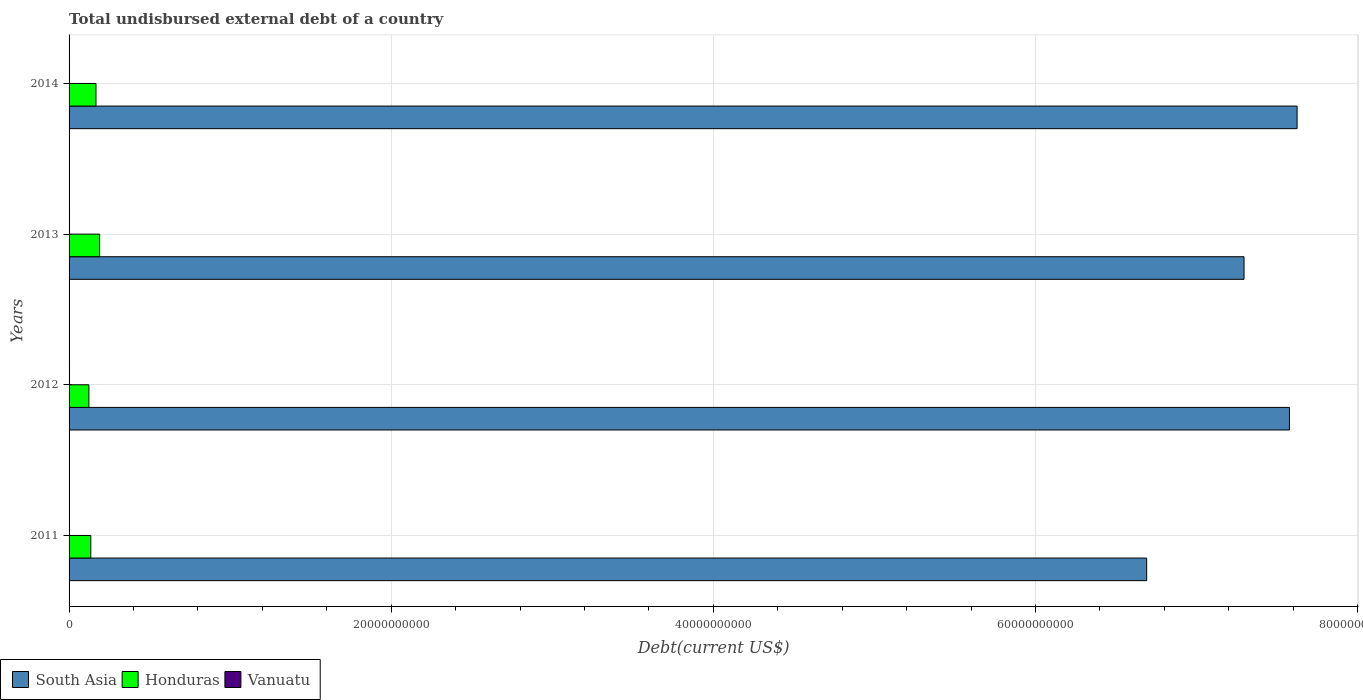How many different coloured bars are there?
Keep it short and to the point. 3. Are the number of bars on each tick of the Y-axis equal?
Offer a terse response. Yes. What is the label of the 2nd group of bars from the top?
Your answer should be compact. 2013. In how many cases, is the number of bars for a given year not equal to the number of legend labels?
Your answer should be very brief. 0. What is the total undisbursed external debt in Vanuatu in 2011?
Keep it short and to the point. 1.28e+07. Across all years, what is the maximum total undisbursed external debt in South Asia?
Ensure brevity in your answer.  7.62e+1. Across all years, what is the minimum total undisbursed external debt in South Asia?
Provide a short and direct response. 6.69e+1. In which year was the total undisbursed external debt in Honduras maximum?
Offer a terse response. 2013. In which year was the total undisbursed external debt in Vanuatu minimum?
Ensure brevity in your answer.  2011. What is the total total undisbursed external debt in Honduras in the graph?
Give a very brief answer. 6.15e+09. What is the difference between the total undisbursed external debt in Honduras in 2011 and that in 2014?
Give a very brief answer. -3.20e+08. What is the difference between the total undisbursed external debt in Honduras in 2011 and the total undisbursed external debt in Vanuatu in 2012?
Your response must be concise. 1.32e+09. What is the average total undisbursed external debt in South Asia per year?
Ensure brevity in your answer.  7.30e+1. In the year 2014, what is the difference between the total undisbursed external debt in Honduras and total undisbursed external debt in Vanuatu?
Offer a terse response. 1.64e+09. What is the ratio of the total undisbursed external debt in Vanuatu in 2011 to that in 2012?
Your response must be concise. 0.46. What is the difference between the highest and the second highest total undisbursed external debt in Vanuatu?
Give a very brief answer. 4.23e+05. What is the difference between the highest and the lowest total undisbursed external debt in South Asia?
Your answer should be very brief. 9.34e+09. In how many years, is the total undisbursed external debt in Vanuatu greater than the average total undisbursed external debt in Vanuatu taken over all years?
Offer a terse response. 3. Is the sum of the total undisbursed external debt in Honduras in 2011 and 2013 greater than the maximum total undisbursed external debt in South Asia across all years?
Keep it short and to the point. No. What does the 1st bar from the top in 2014 represents?
Ensure brevity in your answer.  Vanuatu. What does the 1st bar from the bottom in 2013 represents?
Your response must be concise. South Asia. How many bars are there?
Ensure brevity in your answer.  12. Are all the bars in the graph horizontal?
Provide a short and direct response. Yes. What is the difference between two consecutive major ticks on the X-axis?
Make the answer very short. 2.00e+1. Does the graph contain grids?
Provide a short and direct response. Yes. What is the title of the graph?
Your answer should be very brief. Total undisbursed external debt of a country. Does "Hungary" appear as one of the legend labels in the graph?
Your answer should be very brief. No. What is the label or title of the X-axis?
Give a very brief answer. Debt(current US$). What is the label or title of the Y-axis?
Offer a very short reply. Years. What is the Debt(current US$) of South Asia in 2011?
Give a very brief answer. 6.69e+1. What is the Debt(current US$) of Honduras in 2011?
Your answer should be very brief. 1.35e+09. What is the Debt(current US$) of Vanuatu in 2011?
Provide a short and direct response. 1.28e+07. What is the Debt(current US$) in South Asia in 2012?
Offer a very short reply. 7.58e+1. What is the Debt(current US$) in Honduras in 2012?
Provide a succinct answer. 1.23e+09. What is the Debt(current US$) of Vanuatu in 2012?
Your response must be concise. 2.80e+07. What is the Debt(current US$) of South Asia in 2013?
Offer a very short reply. 7.30e+1. What is the Debt(current US$) in Honduras in 2013?
Make the answer very short. 1.90e+09. What is the Debt(current US$) of Vanuatu in 2013?
Your response must be concise. 2.84e+07. What is the Debt(current US$) of South Asia in 2014?
Provide a succinct answer. 7.62e+1. What is the Debt(current US$) of Honduras in 2014?
Your answer should be compact. 1.67e+09. What is the Debt(current US$) of Vanuatu in 2014?
Provide a succinct answer. 2.74e+07. Across all years, what is the maximum Debt(current US$) in South Asia?
Make the answer very short. 7.62e+1. Across all years, what is the maximum Debt(current US$) of Honduras?
Your response must be concise. 1.90e+09. Across all years, what is the maximum Debt(current US$) of Vanuatu?
Make the answer very short. 2.84e+07. Across all years, what is the minimum Debt(current US$) in South Asia?
Provide a short and direct response. 6.69e+1. Across all years, what is the minimum Debt(current US$) in Honduras?
Provide a short and direct response. 1.23e+09. Across all years, what is the minimum Debt(current US$) of Vanuatu?
Provide a short and direct response. 1.28e+07. What is the total Debt(current US$) in South Asia in the graph?
Your response must be concise. 2.92e+11. What is the total Debt(current US$) of Honduras in the graph?
Your answer should be compact. 6.15e+09. What is the total Debt(current US$) of Vanuatu in the graph?
Ensure brevity in your answer.  9.67e+07. What is the difference between the Debt(current US$) of South Asia in 2011 and that in 2012?
Your answer should be very brief. -8.87e+09. What is the difference between the Debt(current US$) of Honduras in 2011 and that in 2012?
Your response must be concise. 1.19e+08. What is the difference between the Debt(current US$) in Vanuatu in 2011 and that in 2012?
Make the answer very short. -1.52e+07. What is the difference between the Debt(current US$) in South Asia in 2011 and that in 2013?
Ensure brevity in your answer.  -6.04e+09. What is the difference between the Debt(current US$) of Honduras in 2011 and that in 2013?
Keep it short and to the point. -5.49e+08. What is the difference between the Debt(current US$) of Vanuatu in 2011 and that in 2013?
Ensure brevity in your answer.  -1.56e+07. What is the difference between the Debt(current US$) in South Asia in 2011 and that in 2014?
Your answer should be compact. -9.34e+09. What is the difference between the Debt(current US$) in Honduras in 2011 and that in 2014?
Offer a very short reply. -3.20e+08. What is the difference between the Debt(current US$) of Vanuatu in 2011 and that in 2014?
Your answer should be compact. -1.47e+07. What is the difference between the Debt(current US$) of South Asia in 2012 and that in 2013?
Provide a succinct answer. 2.82e+09. What is the difference between the Debt(current US$) in Honduras in 2012 and that in 2013?
Offer a very short reply. -6.67e+08. What is the difference between the Debt(current US$) of Vanuatu in 2012 and that in 2013?
Offer a terse response. -4.23e+05. What is the difference between the Debt(current US$) in South Asia in 2012 and that in 2014?
Your response must be concise. -4.74e+08. What is the difference between the Debt(current US$) of Honduras in 2012 and that in 2014?
Provide a short and direct response. -4.39e+08. What is the difference between the Debt(current US$) of Vanuatu in 2012 and that in 2014?
Make the answer very short. 5.49e+05. What is the difference between the Debt(current US$) of South Asia in 2013 and that in 2014?
Make the answer very short. -3.29e+09. What is the difference between the Debt(current US$) in Honduras in 2013 and that in 2014?
Offer a very short reply. 2.28e+08. What is the difference between the Debt(current US$) of Vanuatu in 2013 and that in 2014?
Offer a terse response. 9.72e+05. What is the difference between the Debt(current US$) of South Asia in 2011 and the Debt(current US$) of Honduras in 2012?
Provide a succinct answer. 6.57e+1. What is the difference between the Debt(current US$) in South Asia in 2011 and the Debt(current US$) in Vanuatu in 2012?
Give a very brief answer. 6.69e+1. What is the difference between the Debt(current US$) in Honduras in 2011 and the Debt(current US$) in Vanuatu in 2012?
Keep it short and to the point. 1.32e+09. What is the difference between the Debt(current US$) in South Asia in 2011 and the Debt(current US$) in Honduras in 2013?
Provide a short and direct response. 6.50e+1. What is the difference between the Debt(current US$) of South Asia in 2011 and the Debt(current US$) of Vanuatu in 2013?
Offer a terse response. 6.69e+1. What is the difference between the Debt(current US$) in Honduras in 2011 and the Debt(current US$) in Vanuatu in 2013?
Your response must be concise. 1.32e+09. What is the difference between the Debt(current US$) of South Asia in 2011 and the Debt(current US$) of Honduras in 2014?
Offer a terse response. 6.52e+1. What is the difference between the Debt(current US$) in South Asia in 2011 and the Debt(current US$) in Vanuatu in 2014?
Offer a very short reply. 6.69e+1. What is the difference between the Debt(current US$) in Honduras in 2011 and the Debt(current US$) in Vanuatu in 2014?
Ensure brevity in your answer.  1.32e+09. What is the difference between the Debt(current US$) in South Asia in 2012 and the Debt(current US$) in Honduras in 2013?
Your response must be concise. 7.39e+1. What is the difference between the Debt(current US$) in South Asia in 2012 and the Debt(current US$) in Vanuatu in 2013?
Ensure brevity in your answer.  7.57e+1. What is the difference between the Debt(current US$) of Honduras in 2012 and the Debt(current US$) of Vanuatu in 2013?
Provide a short and direct response. 1.20e+09. What is the difference between the Debt(current US$) in South Asia in 2012 and the Debt(current US$) in Honduras in 2014?
Provide a short and direct response. 7.41e+1. What is the difference between the Debt(current US$) of South Asia in 2012 and the Debt(current US$) of Vanuatu in 2014?
Ensure brevity in your answer.  7.57e+1. What is the difference between the Debt(current US$) in Honduras in 2012 and the Debt(current US$) in Vanuatu in 2014?
Offer a terse response. 1.20e+09. What is the difference between the Debt(current US$) of South Asia in 2013 and the Debt(current US$) of Honduras in 2014?
Make the answer very short. 7.13e+1. What is the difference between the Debt(current US$) of South Asia in 2013 and the Debt(current US$) of Vanuatu in 2014?
Your answer should be very brief. 7.29e+1. What is the difference between the Debt(current US$) of Honduras in 2013 and the Debt(current US$) of Vanuatu in 2014?
Offer a very short reply. 1.87e+09. What is the average Debt(current US$) of South Asia per year?
Provide a succinct answer. 7.30e+1. What is the average Debt(current US$) of Honduras per year?
Your response must be concise. 1.54e+09. What is the average Debt(current US$) in Vanuatu per year?
Your response must be concise. 2.42e+07. In the year 2011, what is the difference between the Debt(current US$) of South Asia and Debt(current US$) of Honduras?
Offer a terse response. 6.56e+1. In the year 2011, what is the difference between the Debt(current US$) of South Asia and Debt(current US$) of Vanuatu?
Keep it short and to the point. 6.69e+1. In the year 2011, what is the difference between the Debt(current US$) of Honduras and Debt(current US$) of Vanuatu?
Provide a succinct answer. 1.34e+09. In the year 2012, what is the difference between the Debt(current US$) in South Asia and Debt(current US$) in Honduras?
Provide a short and direct response. 7.45e+1. In the year 2012, what is the difference between the Debt(current US$) in South Asia and Debt(current US$) in Vanuatu?
Keep it short and to the point. 7.57e+1. In the year 2012, what is the difference between the Debt(current US$) in Honduras and Debt(current US$) in Vanuatu?
Your response must be concise. 1.20e+09. In the year 2013, what is the difference between the Debt(current US$) of South Asia and Debt(current US$) of Honduras?
Give a very brief answer. 7.11e+1. In the year 2013, what is the difference between the Debt(current US$) in South Asia and Debt(current US$) in Vanuatu?
Ensure brevity in your answer.  7.29e+1. In the year 2013, what is the difference between the Debt(current US$) in Honduras and Debt(current US$) in Vanuatu?
Provide a succinct answer. 1.87e+09. In the year 2014, what is the difference between the Debt(current US$) in South Asia and Debt(current US$) in Honduras?
Provide a short and direct response. 7.46e+1. In the year 2014, what is the difference between the Debt(current US$) of South Asia and Debt(current US$) of Vanuatu?
Offer a very short reply. 7.62e+1. In the year 2014, what is the difference between the Debt(current US$) of Honduras and Debt(current US$) of Vanuatu?
Keep it short and to the point. 1.64e+09. What is the ratio of the Debt(current US$) of South Asia in 2011 to that in 2012?
Offer a very short reply. 0.88. What is the ratio of the Debt(current US$) in Honduras in 2011 to that in 2012?
Ensure brevity in your answer.  1.1. What is the ratio of the Debt(current US$) of Vanuatu in 2011 to that in 2012?
Offer a terse response. 0.46. What is the ratio of the Debt(current US$) of South Asia in 2011 to that in 2013?
Make the answer very short. 0.92. What is the ratio of the Debt(current US$) in Honduras in 2011 to that in 2013?
Make the answer very short. 0.71. What is the ratio of the Debt(current US$) in Vanuatu in 2011 to that in 2013?
Give a very brief answer. 0.45. What is the ratio of the Debt(current US$) of South Asia in 2011 to that in 2014?
Ensure brevity in your answer.  0.88. What is the ratio of the Debt(current US$) of Honduras in 2011 to that in 2014?
Offer a terse response. 0.81. What is the ratio of the Debt(current US$) in Vanuatu in 2011 to that in 2014?
Offer a terse response. 0.47. What is the ratio of the Debt(current US$) of South Asia in 2012 to that in 2013?
Provide a succinct answer. 1.04. What is the ratio of the Debt(current US$) in Honduras in 2012 to that in 2013?
Give a very brief answer. 0.65. What is the ratio of the Debt(current US$) in Vanuatu in 2012 to that in 2013?
Offer a very short reply. 0.99. What is the ratio of the Debt(current US$) of South Asia in 2012 to that in 2014?
Your response must be concise. 0.99. What is the ratio of the Debt(current US$) of Honduras in 2012 to that in 2014?
Provide a short and direct response. 0.74. What is the ratio of the Debt(current US$) of Vanuatu in 2012 to that in 2014?
Offer a terse response. 1.02. What is the ratio of the Debt(current US$) of South Asia in 2013 to that in 2014?
Your response must be concise. 0.96. What is the ratio of the Debt(current US$) of Honduras in 2013 to that in 2014?
Provide a succinct answer. 1.14. What is the ratio of the Debt(current US$) in Vanuatu in 2013 to that in 2014?
Provide a succinct answer. 1.04. What is the difference between the highest and the second highest Debt(current US$) in South Asia?
Your answer should be very brief. 4.74e+08. What is the difference between the highest and the second highest Debt(current US$) of Honduras?
Ensure brevity in your answer.  2.28e+08. What is the difference between the highest and the second highest Debt(current US$) in Vanuatu?
Provide a succinct answer. 4.23e+05. What is the difference between the highest and the lowest Debt(current US$) in South Asia?
Give a very brief answer. 9.34e+09. What is the difference between the highest and the lowest Debt(current US$) of Honduras?
Offer a very short reply. 6.67e+08. What is the difference between the highest and the lowest Debt(current US$) of Vanuatu?
Your response must be concise. 1.56e+07. 